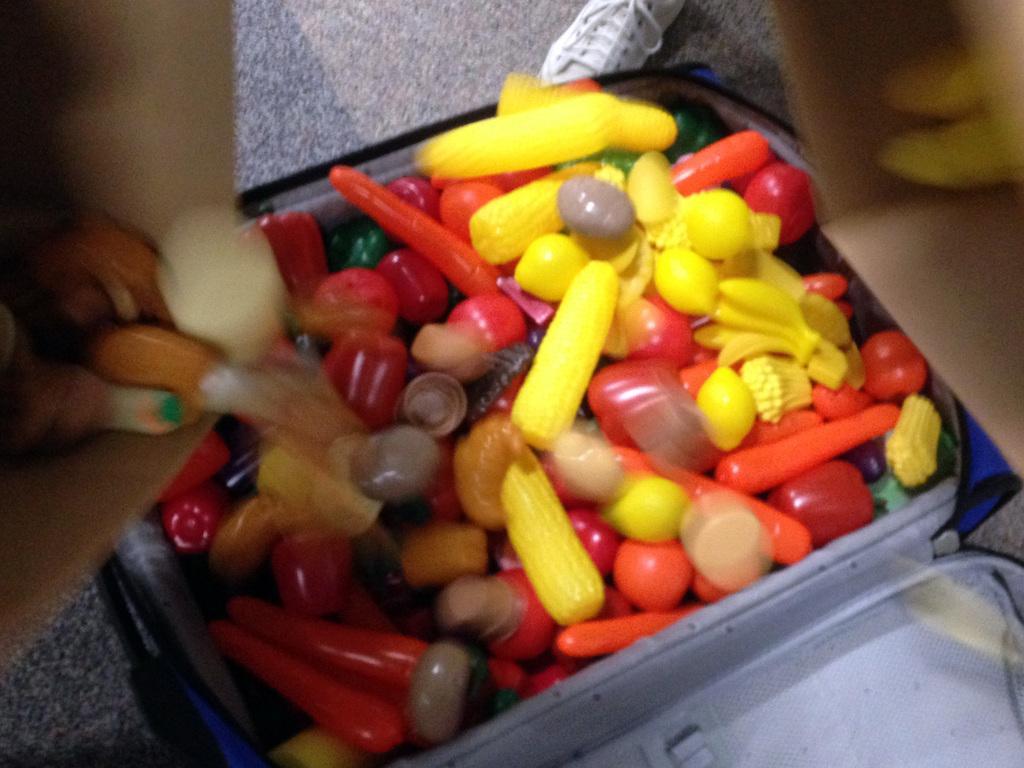Please provide a concise description of this image. In this picture, we see a box or the suitcase containing plastic fruits. These fruits are in yellow, red and orange color. On the left side, we see an object in brown color. On the right side, it is brown in color. In the background, we see a white shoe and a grey carpet. 